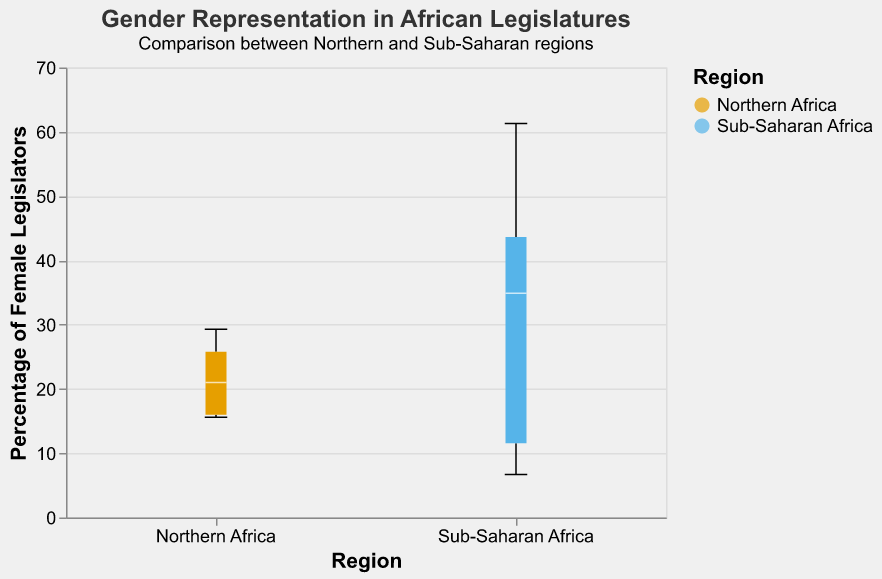What is the title of the figure? The title is typically displayed at the top of the plot. In this case, the title is "Gender Representation in African Legislatures".
Answer: "Gender Representation in African Legislatures" What are the regions compared in the figure? The figure uses a grouped box plot to compare two regions. According to the x-axis labels, these regions are "Northern Africa" and "Sub-Saharan Africa".
Answer: "Northern Africa" and "Sub-Saharan Africa" Which region has a higher median percentage of female legislators? Compare the white lines representing the median inside the box plots of both regions. The median percentage for Sub-Saharan Africa is higher than that for Northern Africa.
Answer: Sub-Saharan Africa What is the minimum percentage of female legislators in Northern Africa? The minimum value for the Northern Africa box plot is at the lower whisker end. The lowest value for Northern Africa is for Egypt at 15.6%.
Answer: 15.6% Which country has the highest percentage of female legislators in Sub-Saharan Africa? Check the data and the corresponding maximum whisker extension in the Sub-Saharan Africa box plot. Rwanda has the highest percentage at 61.3%.
Answer: Rwanda What is the difference between the median percentage of female legislators in Northern and Sub-Saharan Africa? Identify the medians from the plots: Northern Africa’s median appears to be around 21%, and Sub-Saharan Africa’s median is around 34.9%. Subtract Northern Africa's median from Sub-Saharan Africa's median: 34.9% - 21% = 13.9%.
Answer: 13.9% How many countries are represented in the Sub-Saharan Africa group? By counting the data points provided in the text, there are seven countries listed for Sub-Saharan Africa.
Answer: 7 Which region shows a wider range (min-max) of female representation in legislatures? The range can be determined by subtracting the minimum value from the maximum value for each region: 
- Northern Africa: 29.3% - 15.6% = 13.7%
- Sub-Saharan Africa: 61.3% - 6.7% = 54.6%
Sub-Saharan Africa has a wider range.
Answer: Sub-Saharan Africa Are there any outlier values in the Northern Africa region, and if so, which countries do they belong to? Outliers are typically shown as individual points beyond the whiskers of the box plot. Northern Africa does not display any outliers in this figure.
Answer: No outliers in Northern Africa 